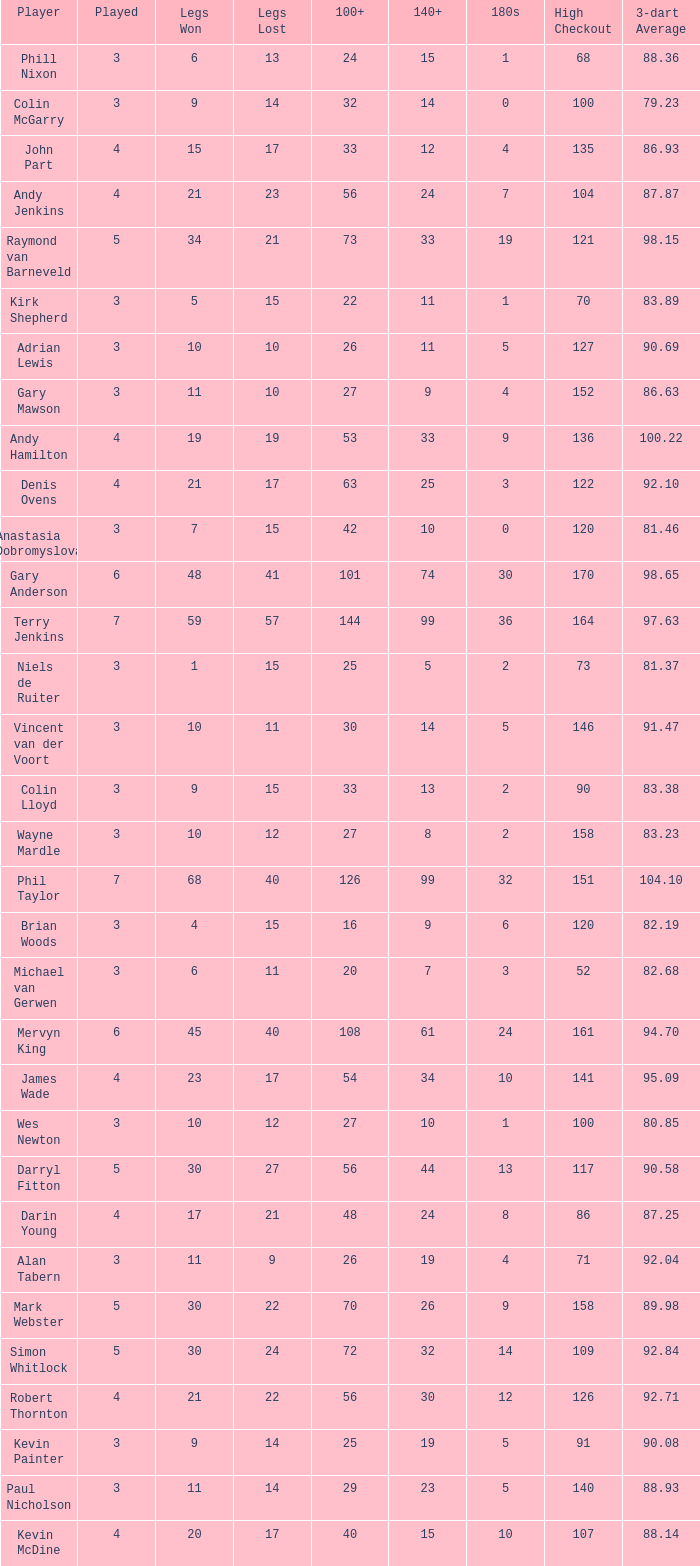What is the number of high checkout when legs Lost is 17, 140+ is 15, and played is larger than 4? None. 